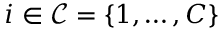Convert formula to latex. <formula><loc_0><loc_0><loc_500><loc_500>i \in \mathcal { C } = \{ 1 , \dots , C \}</formula> 